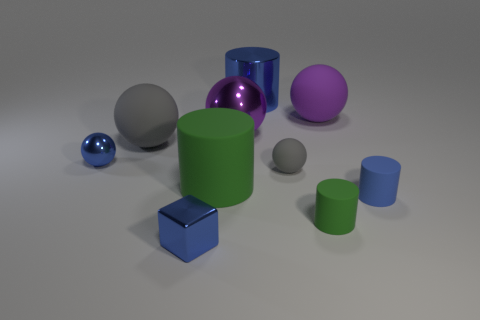What number of objects are either purple rubber objects or tiny purple matte cubes?
Give a very brief answer. 1. What number of other objects are there of the same shape as the tiny gray rubber thing?
Offer a very short reply. 4. Is the material of the large blue cylinder behind the big gray matte sphere the same as the large cylinder in front of the small shiny sphere?
Offer a terse response. No. The matte thing that is on the left side of the tiny gray sphere and in front of the small gray ball has what shape?
Offer a terse response. Cylinder. Are there any other things that are made of the same material as the blue cube?
Offer a very short reply. Yes. There is a small blue thing that is behind the tiny shiny block and in front of the tiny metal sphere; what material is it?
Offer a terse response. Rubber. There is a big purple thing that is made of the same material as the tiny green cylinder; what is its shape?
Provide a short and direct response. Sphere. Is there any other thing that is the same color as the large shiny sphere?
Provide a succinct answer. Yes. Is the number of large green rubber objects behind the big purple matte sphere greater than the number of tiny balls?
Ensure brevity in your answer.  No. What is the large green object made of?
Give a very brief answer. Rubber. 